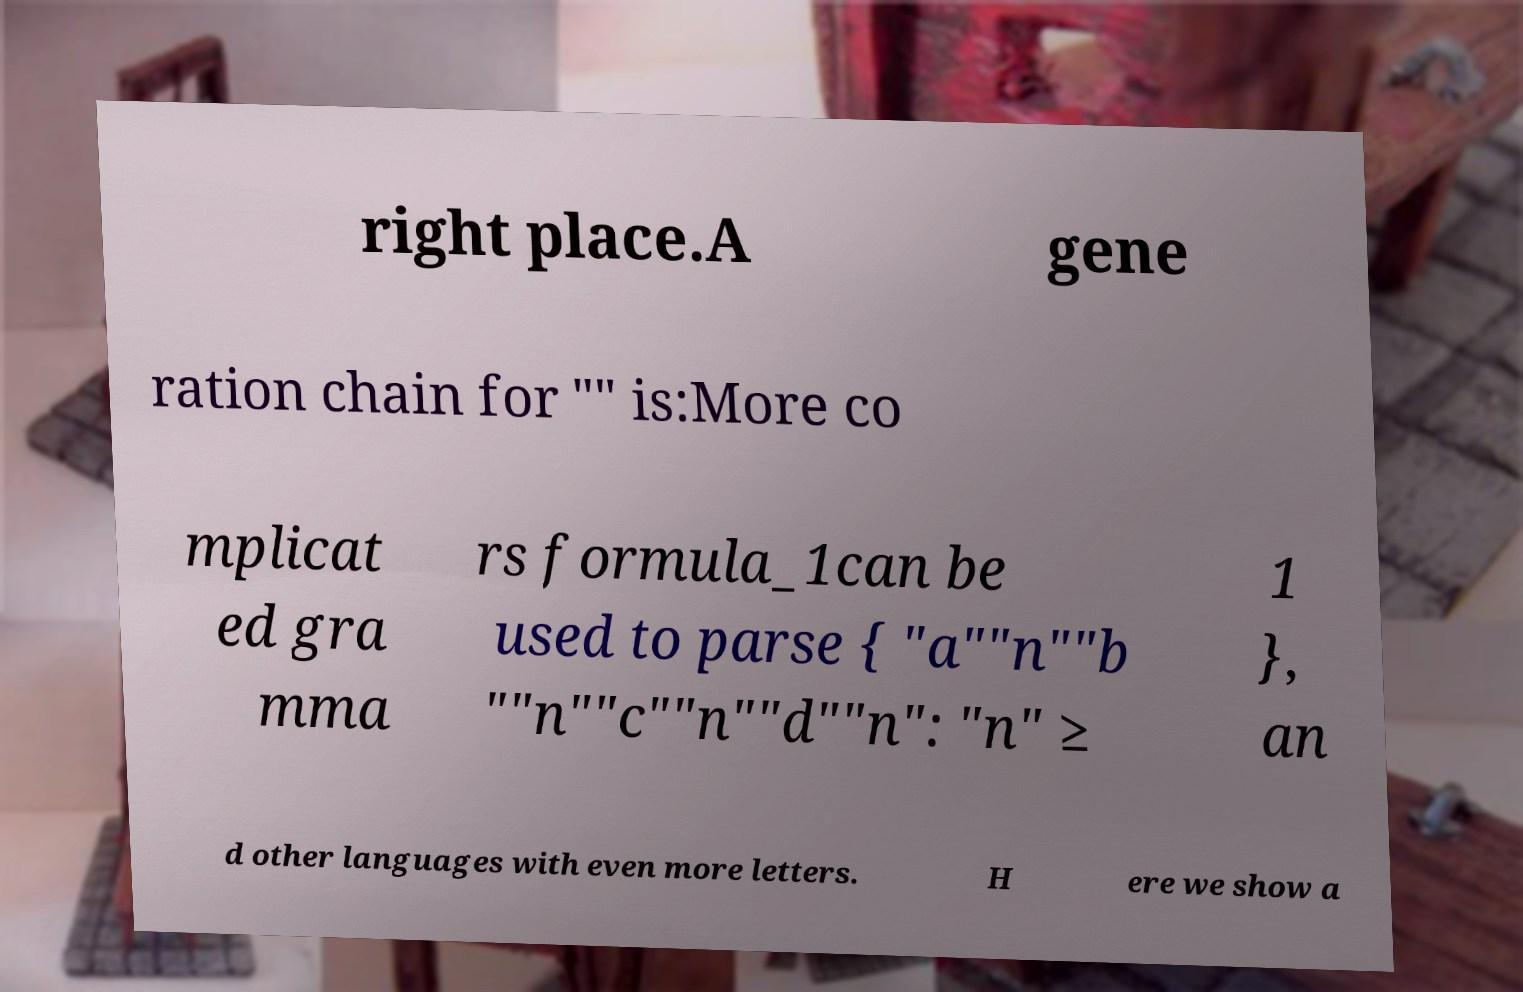Could you extract and type out the text from this image? right place.A gene ration chain for "" is:More co mplicat ed gra mma rs formula_1can be used to parse { "a""n""b ""n""c""n""d""n": "n" ≥ 1 }, an d other languages with even more letters. H ere we show a 